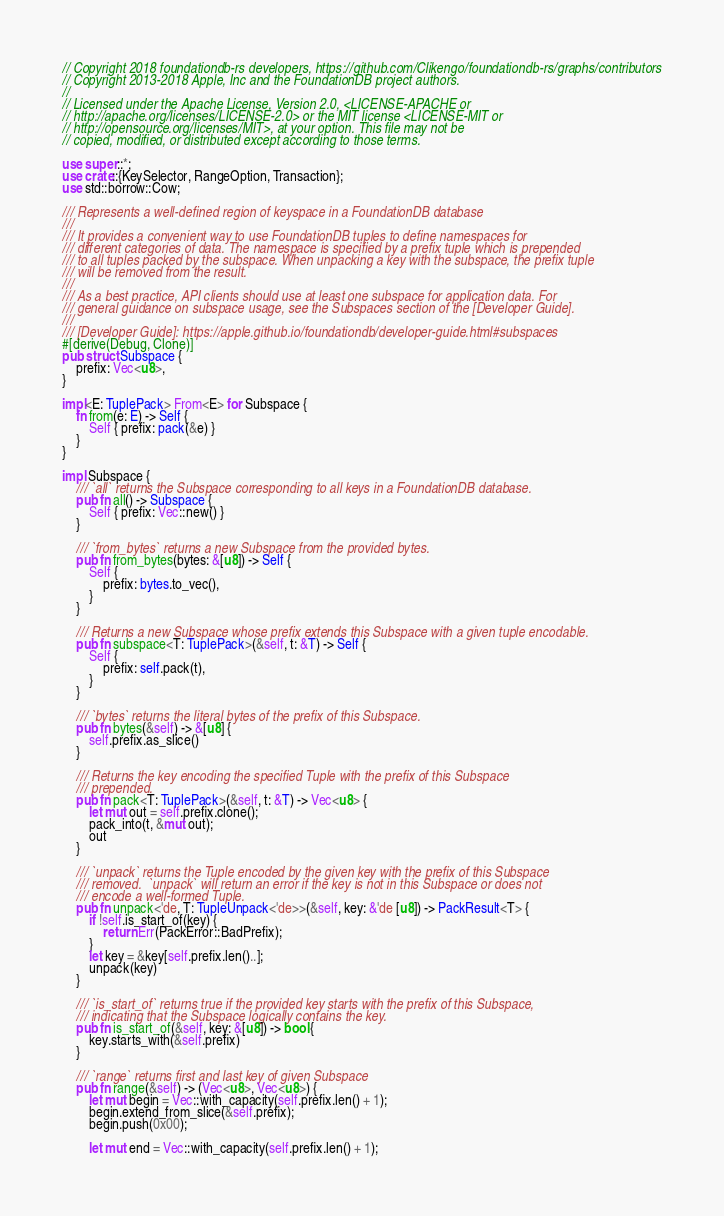Convert code to text. <code><loc_0><loc_0><loc_500><loc_500><_Rust_>// Copyright 2018 foundationdb-rs developers, https://github.com/Clikengo/foundationdb-rs/graphs/contributors
// Copyright 2013-2018 Apple, Inc and the FoundationDB project authors.
//
// Licensed under the Apache License, Version 2.0, <LICENSE-APACHE or
// http://apache.org/licenses/LICENSE-2.0> or the MIT license <LICENSE-MIT or
// http://opensource.org/licenses/MIT>, at your option. This file may not be
// copied, modified, or distributed except according to those terms.

use super::*;
use crate::{KeySelector, RangeOption, Transaction};
use std::borrow::Cow;

/// Represents a well-defined region of keyspace in a FoundationDB database
///
/// It provides a convenient way to use FoundationDB tuples to define namespaces for
/// different categories of data. The namespace is specified by a prefix tuple which is prepended
/// to all tuples packed by the subspace. When unpacking a key with the subspace, the prefix tuple
/// will be removed from the result.
///
/// As a best practice, API clients should use at least one subspace for application data. For
/// general guidance on subspace usage, see the Subspaces section of the [Developer Guide].
///
/// [Developer Guide]: https://apple.github.io/foundationdb/developer-guide.html#subspaces
#[derive(Debug, Clone)]
pub struct Subspace {
    prefix: Vec<u8>,
}

impl<E: TuplePack> From<E> for Subspace {
    fn from(e: E) -> Self {
        Self { prefix: pack(&e) }
    }
}

impl Subspace {
    /// `all` returns the Subspace corresponding to all keys in a FoundationDB database.
    pub fn all() -> Subspace {
        Self { prefix: Vec::new() }
    }

    /// `from_bytes` returns a new Subspace from the provided bytes.
    pub fn from_bytes(bytes: &[u8]) -> Self {
        Self {
            prefix: bytes.to_vec(),
        }
    }

    /// Returns a new Subspace whose prefix extends this Subspace with a given tuple encodable.
    pub fn subspace<T: TuplePack>(&self, t: &T) -> Self {
        Self {
            prefix: self.pack(t),
        }
    }

    /// `bytes` returns the literal bytes of the prefix of this Subspace.
    pub fn bytes(&self) -> &[u8] {
        self.prefix.as_slice()
    }

    /// Returns the key encoding the specified Tuple with the prefix of this Subspace
    /// prepended.
    pub fn pack<T: TuplePack>(&self, t: &T) -> Vec<u8> {
        let mut out = self.prefix.clone();
        pack_into(t, &mut out);
        out
    }

    /// `unpack` returns the Tuple encoded by the given key with the prefix of this Subspace
    /// removed.  `unpack` will return an error if the key is not in this Subspace or does not
    /// encode a well-formed Tuple.
    pub fn unpack<'de, T: TupleUnpack<'de>>(&self, key: &'de [u8]) -> PackResult<T> {
        if !self.is_start_of(key) {
            return Err(PackError::BadPrefix);
        }
        let key = &key[self.prefix.len()..];
        unpack(key)
    }

    /// `is_start_of` returns true if the provided key starts with the prefix of this Subspace,
    /// indicating that the Subspace logically contains the key.
    pub fn is_start_of(&self, key: &[u8]) -> bool {
        key.starts_with(&self.prefix)
    }

    /// `range` returns first and last key of given Subspace
    pub fn range(&self) -> (Vec<u8>, Vec<u8>) {
        let mut begin = Vec::with_capacity(self.prefix.len() + 1);
        begin.extend_from_slice(&self.prefix);
        begin.push(0x00);

        let mut end = Vec::with_capacity(self.prefix.len() + 1);</code> 